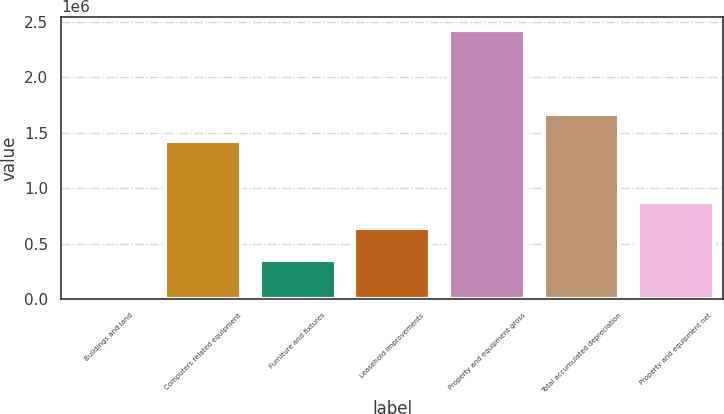Convert chart. <chart><loc_0><loc_0><loc_500><loc_500><bar_chart><fcel>Buildings and land<fcel>Computers related equipment<fcel>Furniture and fixtures<fcel>Leasehold improvements<fcel>Property and equipment gross<fcel>Total accumulated depreciation<fcel>Property and equipment net<nl><fcel>4424<fcel>1.42981e+06<fcel>353773<fcel>637841<fcel>2.42585e+06<fcel>1.67195e+06<fcel>879984<nl></chart> 